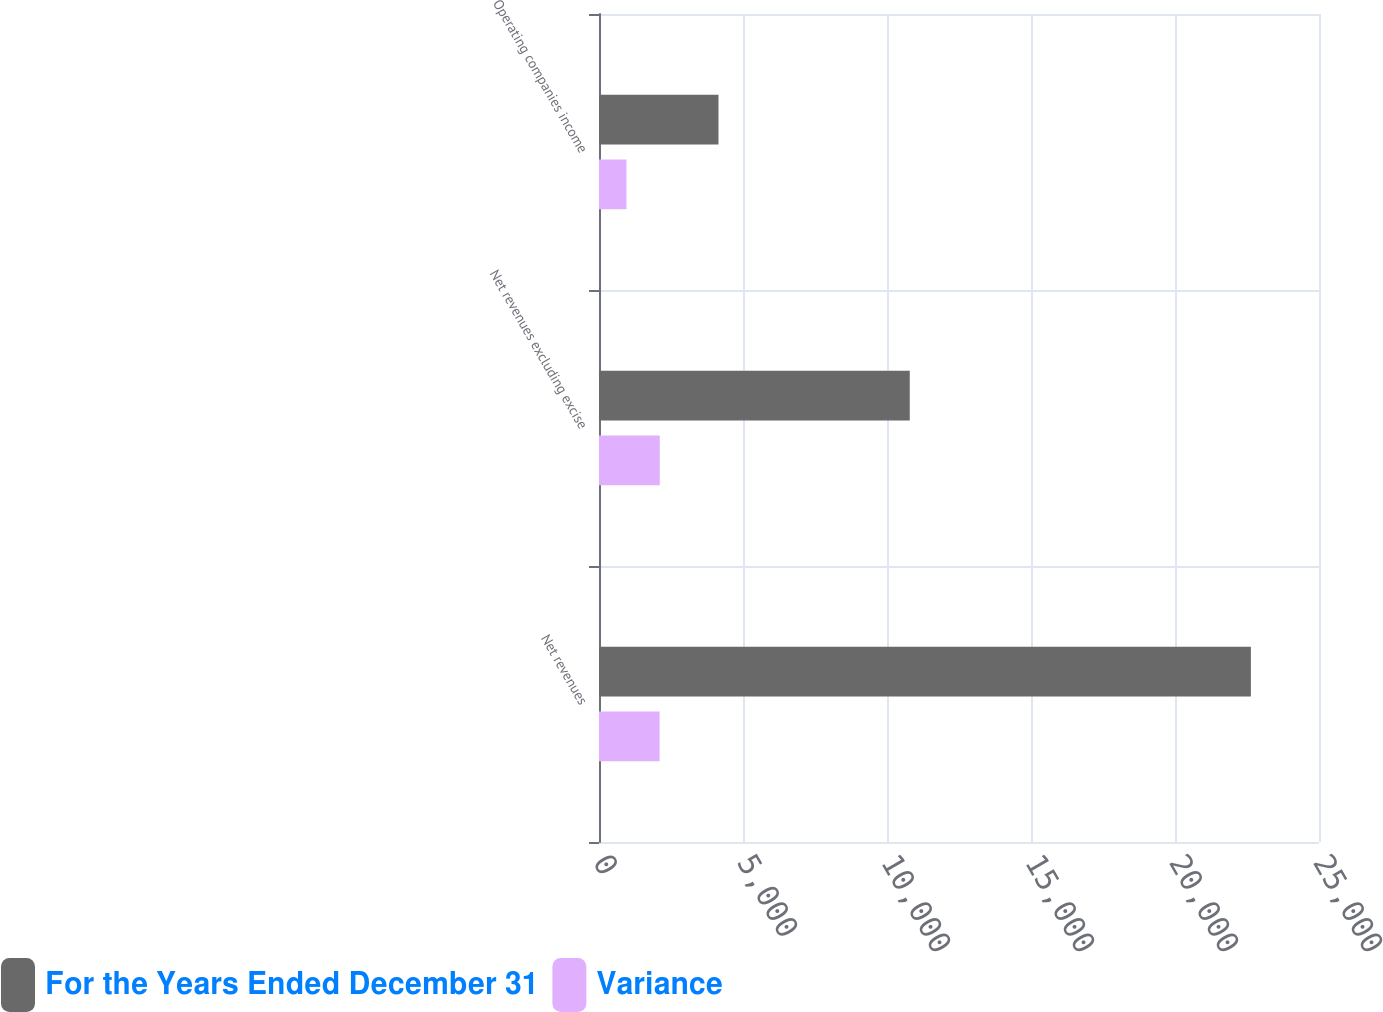Convert chart to OTSL. <chart><loc_0><loc_0><loc_500><loc_500><stacked_bar_chart><ecel><fcel>Net revenues<fcel>Net revenues excluding excise<fcel>Operating companies income<nl><fcel>For the Years Ended December 31<fcel>22635<fcel>10790<fcel>4149<nl><fcel>Variance<fcel>2104<fcel>2109<fcel>953<nl></chart> 